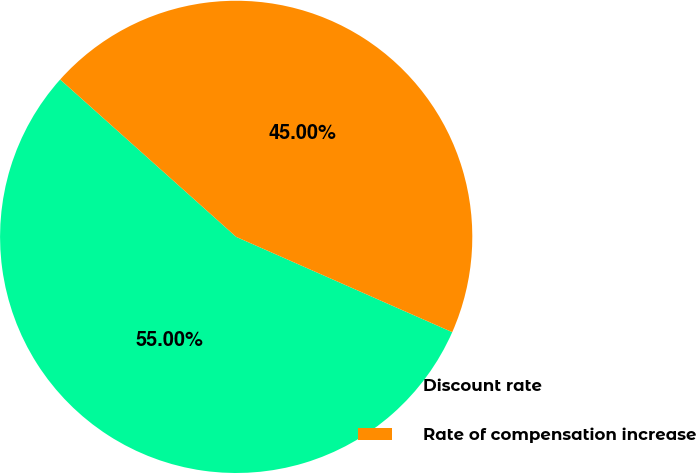<chart> <loc_0><loc_0><loc_500><loc_500><pie_chart><fcel>Discount rate<fcel>Rate of compensation increase<nl><fcel>55.0%<fcel>45.0%<nl></chart> 